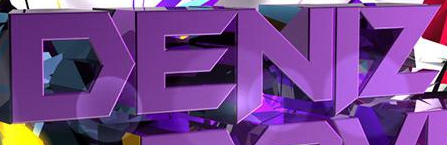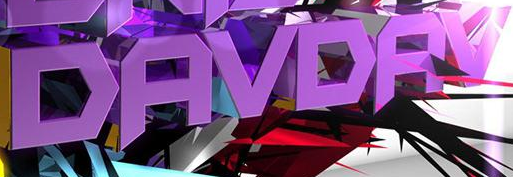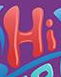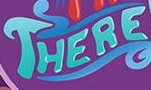What text appears in these images from left to right, separated by a semicolon? DENIZ; DAVDAV; Hi; THERE 